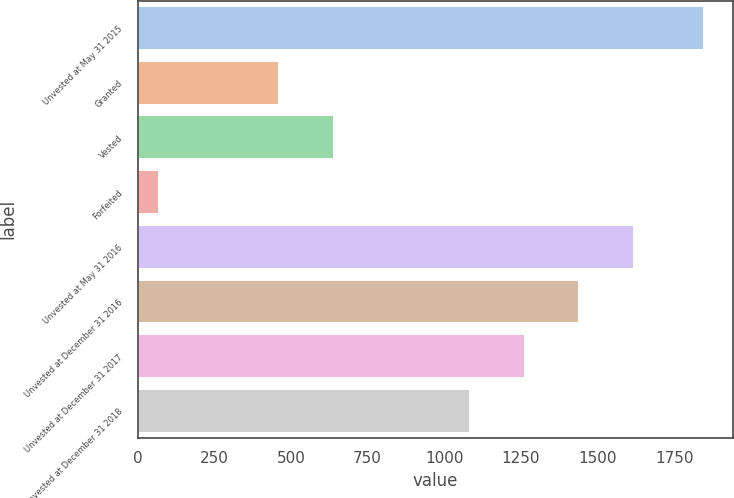Convert chart. <chart><loc_0><loc_0><loc_500><loc_500><bar_chart><fcel>Unvested at May 31 2015<fcel>Granted<fcel>Vested<fcel>Forfeited<fcel>Unvested at May 31 2016<fcel>Unvested at December 31 2016<fcel>Unvested at December 31 2017<fcel>Unvested at December 31 2018<nl><fcel>1848<fcel>461<fcel>638.8<fcel>70<fcel>1617.4<fcel>1439.6<fcel>1261.8<fcel>1084<nl></chart> 